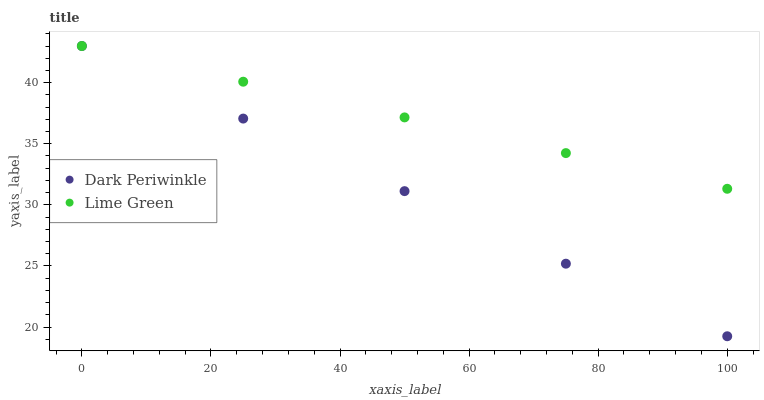Does Dark Periwinkle have the minimum area under the curve?
Answer yes or no. Yes. Does Lime Green have the maximum area under the curve?
Answer yes or no. Yes. Does Dark Periwinkle have the maximum area under the curve?
Answer yes or no. No. Is Dark Periwinkle the smoothest?
Answer yes or no. Yes. Is Lime Green the roughest?
Answer yes or no. Yes. Is Dark Periwinkle the roughest?
Answer yes or no. No. Does Dark Periwinkle have the lowest value?
Answer yes or no. Yes. Does Dark Periwinkle have the highest value?
Answer yes or no. Yes. Does Lime Green intersect Dark Periwinkle?
Answer yes or no. Yes. Is Lime Green less than Dark Periwinkle?
Answer yes or no. No. Is Lime Green greater than Dark Periwinkle?
Answer yes or no. No. 